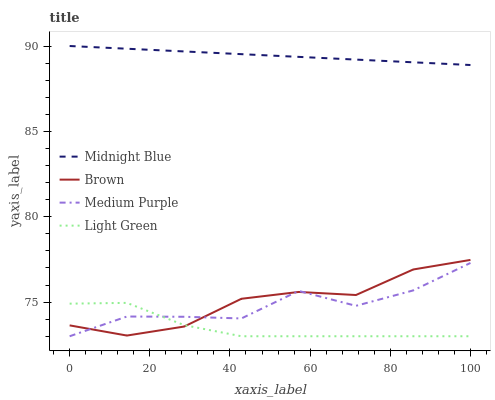Does Light Green have the minimum area under the curve?
Answer yes or no. Yes. Does Brown have the minimum area under the curve?
Answer yes or no. No. Does Brown have the maximum area under the curve?
Answer yes or no. No. Is Brown the smoothest?
Answer yes or no. No. Is Brown the roughest?
Answer yes or no. No. Does Brown have the lowest value?
Answer yes or no. No. Does Brown have the highest value?
Answer yes or no. No. Is Light Green less than Midnight Blue?
Answer yes or no. Yes. Is Midnight Blue greater than Brown?
Answer yes or no. Yes. Does Light Green intersect Midnight Blue?
Answer yes or no. No. 